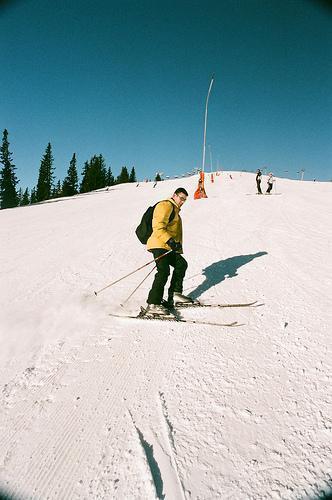How many people are in the photo?
Give a very brief answer. 4. How many people are in the air doing flips?
Give a very brief answer. 0. 